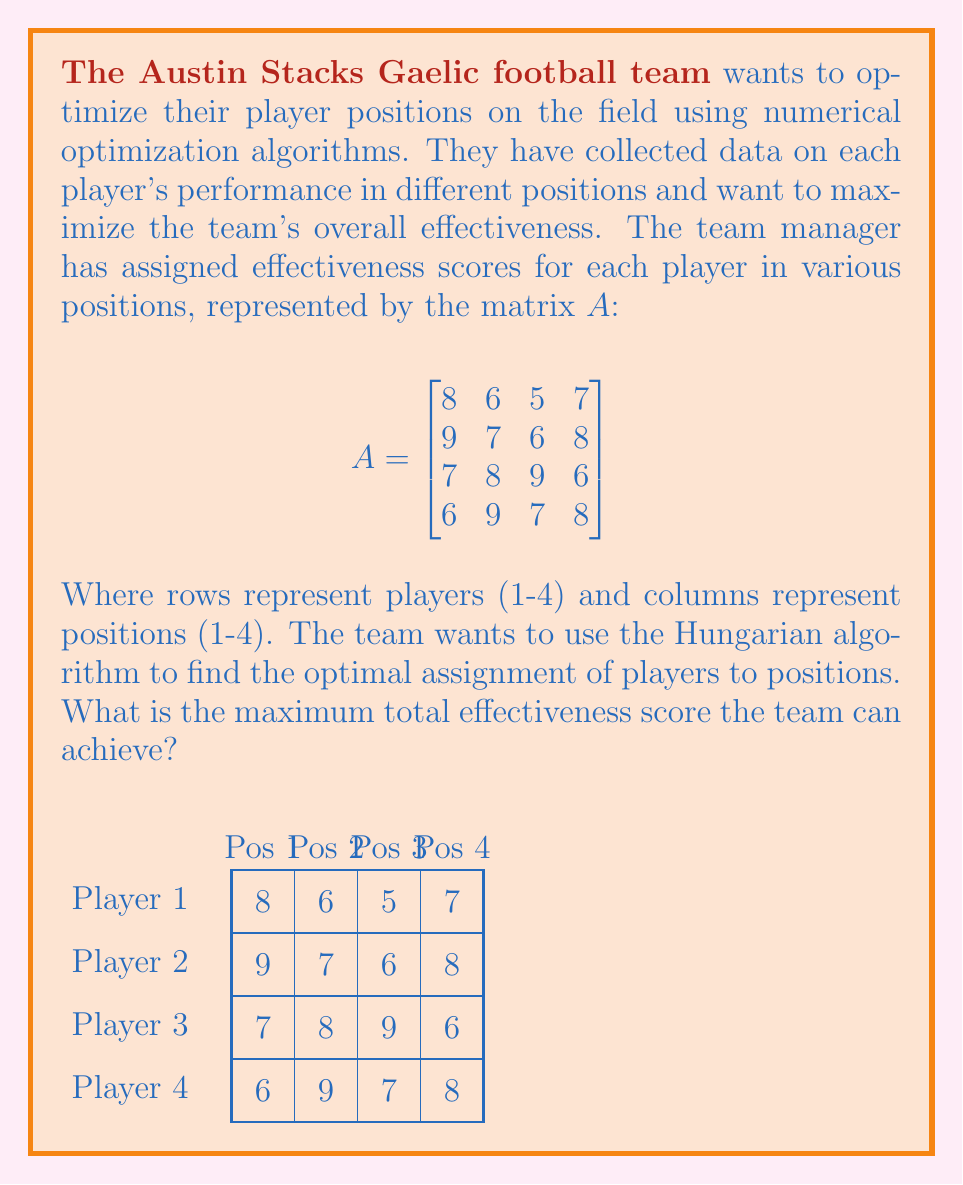Help me with this question. To solve this problem using the Hungarian algorithm, we'll follow these steps:

1) Step 1: Subtract the smallest element in each row from all elements in that row.
$$\begin{bmatrix}
3 & 1 & 0 & 2 \\
3 & 1 & 0 & 2 \\
0 & 1 & 2 & 0 \\
0 & 3 & 1 & 2
\end{bmatrix}$$

2) Step 2: Subtract the smallest element in each column from all elements in that column.
$$\begin{bmatrix}
3 & 0 & 0 & 2 \\
3 & 0 & 0 & 2 \\
0 & 0 & 2 & 0 \\
0 & 2 & 1 & 2
\end{bmatrix}$$

3) Step 3: Draw lines through rows and columns to cover all zeros using the minimum number of lines.
We need 3 lines, which is less than 4 (the matrix size), so we continue.

4) Step 4: Find the smallest uncovered element (1), subtract it from all uncovered elements, and add it to elements at the intersection of covering lines.
$$\begin{bmatrix}
2 & 0 & 0 & 1 \\
2 & 0 & 0 & 1 \\
0 & 1 & 2 & 0 \\
0 & 3 & 1 & 2
\end{bmatrix}$$

5) Repeat steps 3 and 4 until the number of lines equals the matrix size.
After one more iteration:
$$\begin{bmatrix}
2 & 0 & 0 & 1 \\
2 & 0 & 0 & 1 \\
0 & 1 & 2 & 0 \\
0 & 3 & 1 & 2
\end{bmatrix}$$
Now we can cover all zeros with 4 lines.

6) Step 5: Select zeros to find the optimal assignment. Each row and column should have only one selected zero.

The optimal assignment is:
- Player 1 to Position 2
- Player 2 to Position 3
- Player 3 to Position 1
- Player 4 to Position 4

7) Calculate the total effectiveness score by summing the original matrix values for these positions:
$6 + 6 + 7 + 8 = 27$
Answer: 27 